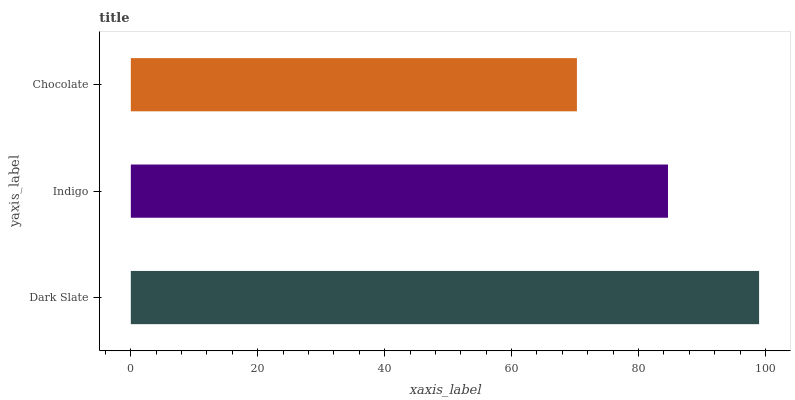Is Chocolate the minimum?
Answer yes or no. Yes. Is Dark Slate the maximum?
Answer yes or no. Yes. Is Indigo the minimum?
Answer yes or no. No. Is Indigo the maximum?
Answer yes or no. No. Is Dark Slate greater than Indigo?
Answer yes or no. Yes. Is Indigo less than Dark Slate?
Answer yes or no. Yes. Is Indigo greater than Dark Slate?
Answer yes or no. No. Is Dark Slate less than Indigo?
Answer yes or no. No. Is Indigo the high median?
Answer yes or no. Yes. Is Indigo the low median?
Answer yes or no. Yes. Is Dark Slate the high median?
Answer yes or no. No. Is Chocolate the low median?
Answer yes or no. No. 